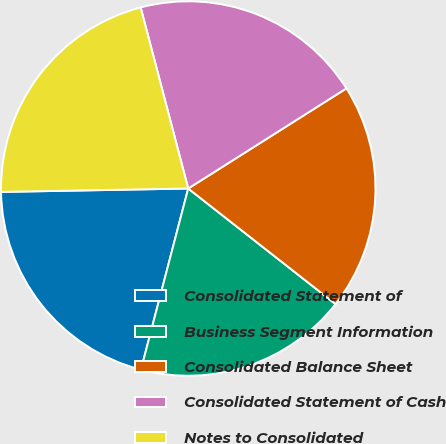Convert chart to OTSL. <chart><loc_0><loc_0><loc_500><loc_500><pie_chart><fcel>Consolidated Statement of<fcel>Business Segment Information<fcel>Consolidated Balance Sheet<fcel>Consolidated Statement of Cash<fcel>Notes to Consolidated<nl><fcel>20.65%<fcel>18.48%<fcel>19.57%<fcel>20.11%<fcel>21.2%<nl></chart> 